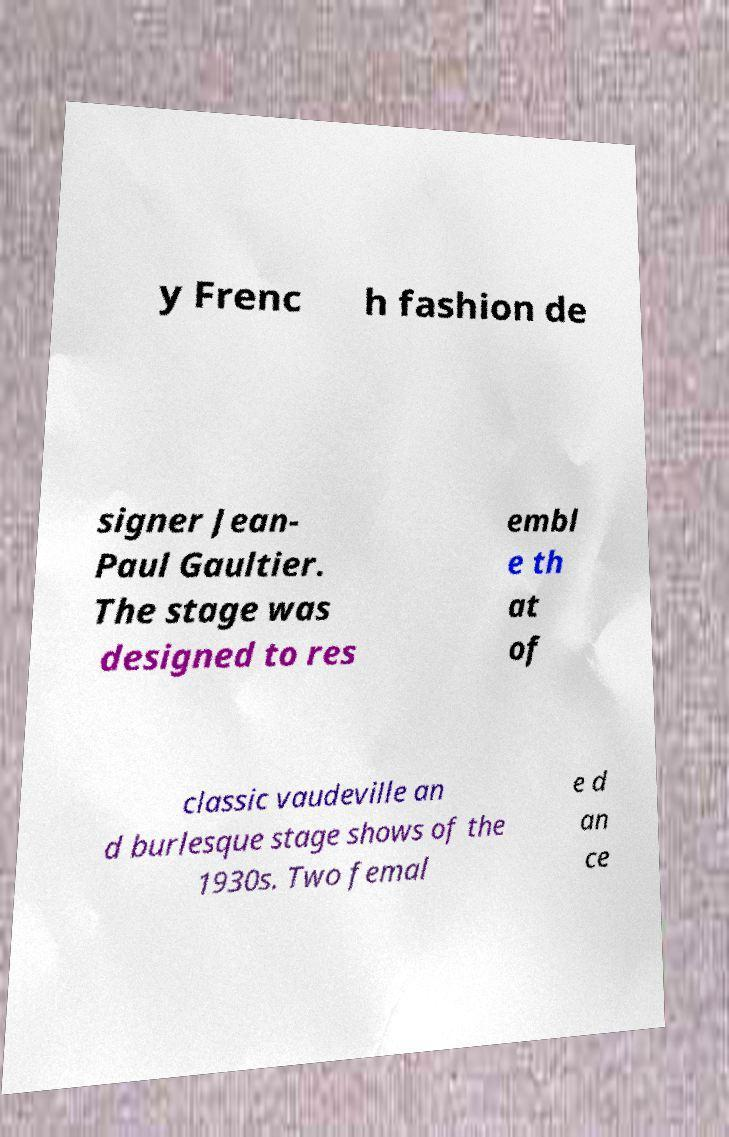Could you extract and type out the text from this image? y Frenc h fashion de signer Jean- Paul Gaultier. The stage was designed to res embl e th at of classic vaudeville an d burlesque stage shows of the 1930s. Two femal e d an ce 